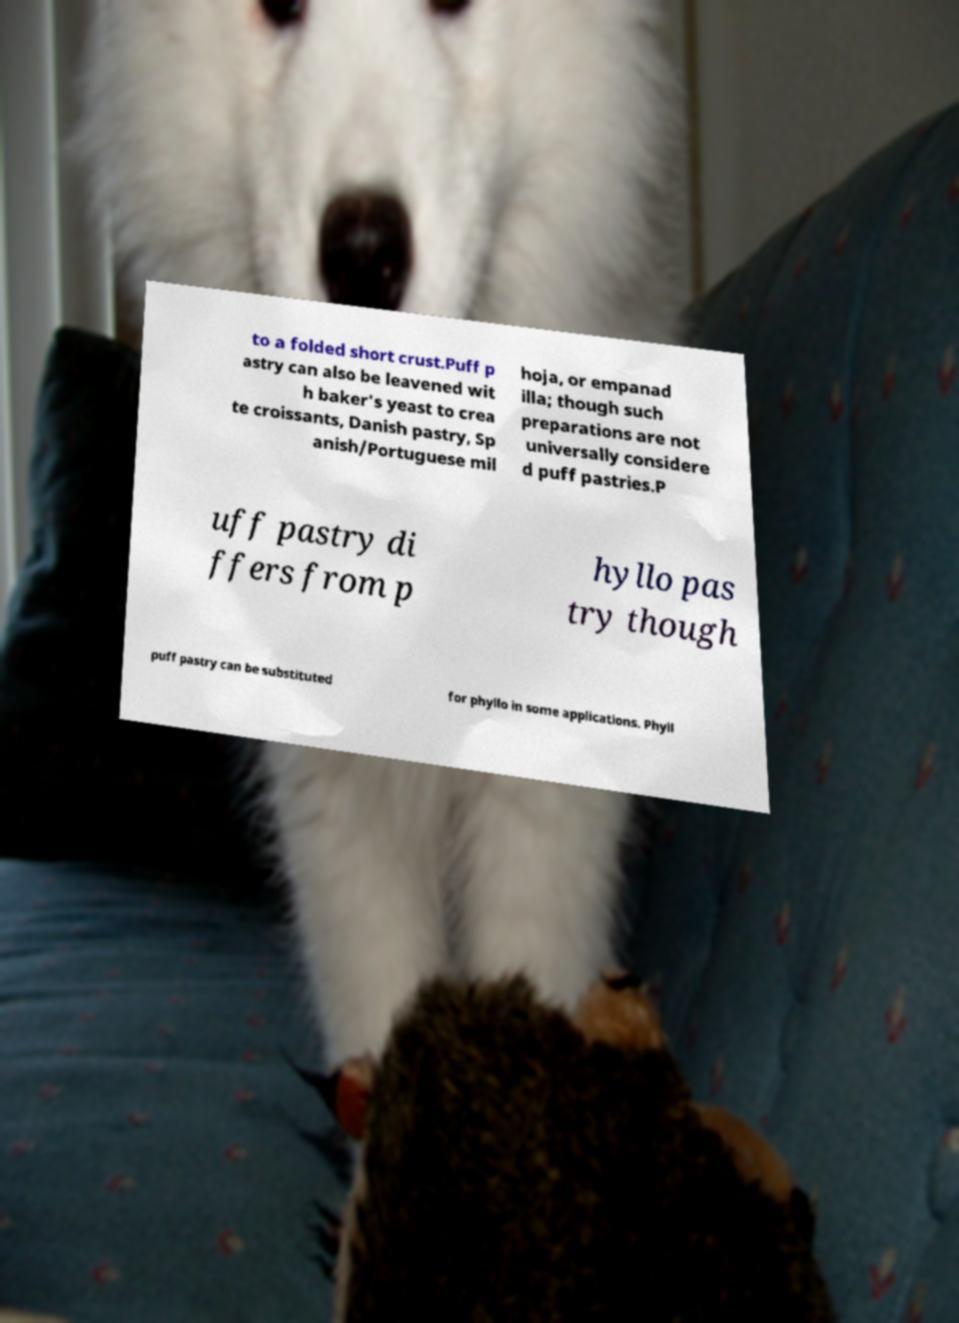I need the written content from this picture converted into text. Can you do that? to a folded short crust.Puff p astry can also be leavened wit h baker's yeast to crea te croissants, Danish pastry, Sp anish/Portuguese mil hoja, or empanad illa; though such preparations are not universally considere d puff pastries.P uff pastry di ffers from p hyllo pas try though puff pastry can be substituted for phyllo in some applications. Phyll 